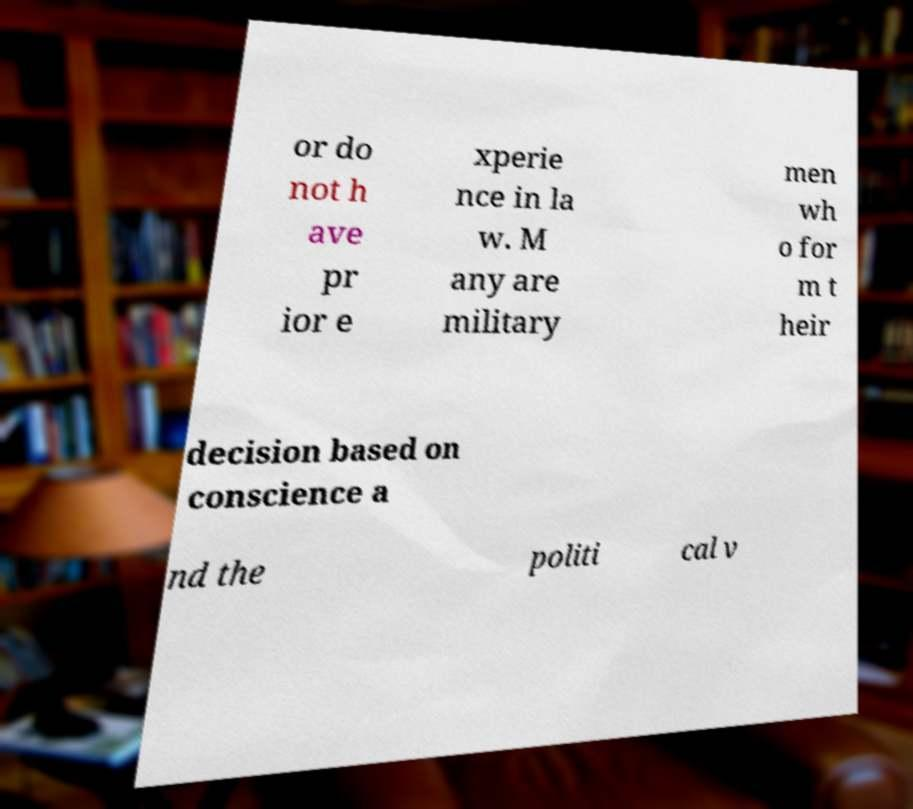There's text embedded in this image that I need extracted. Can you transcribe it verbatim? or do not h ave pr ior e xperie nce in la w. M any are military men wh o for m t heir decision based on conscience a nd the politi cal v 